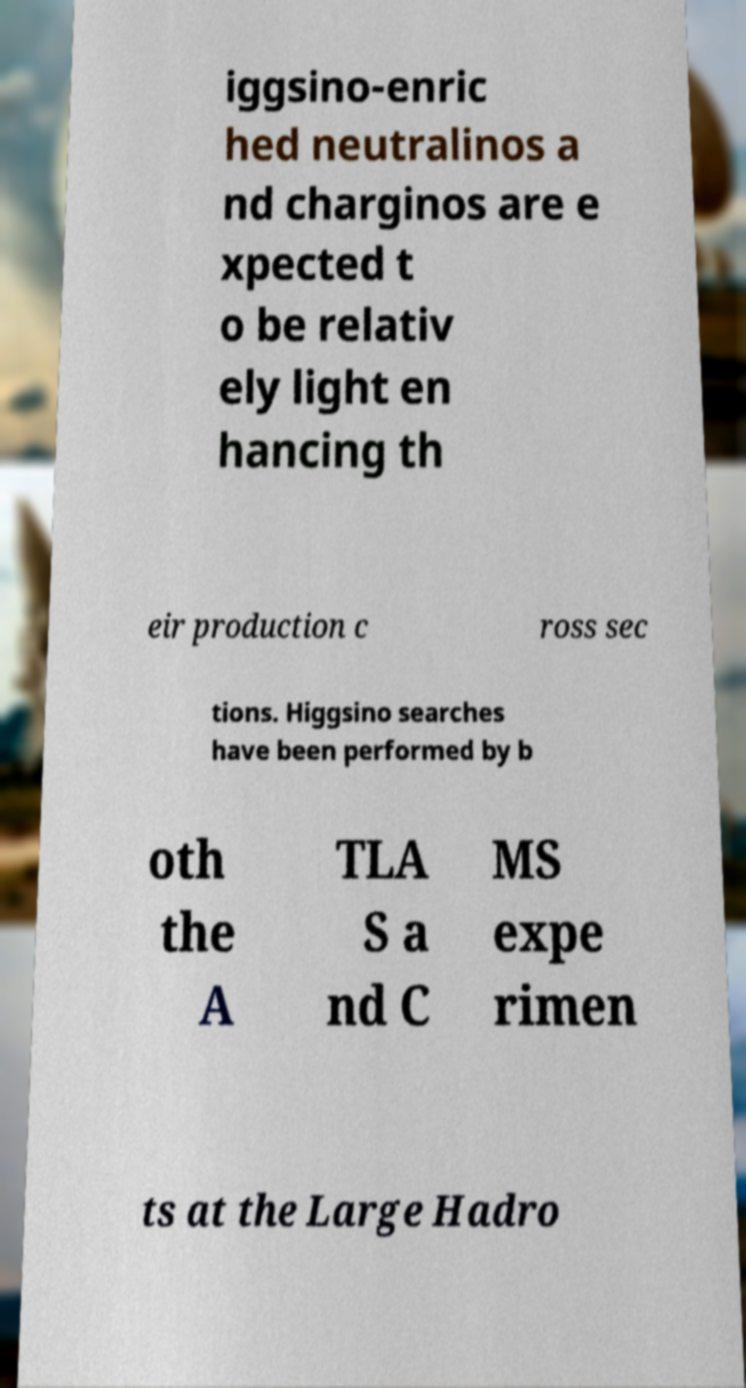There's text embedded in this image that I need extracted. Can you transcribe it verbatim? iggsino-enric hed neutralinos a nd charginos are e xpected t o be relativ ely light en hancing th eir production c ross sec tions. Higgsino searches have been performed by b oth the A TLA S a nd C MS expe rimen ts at the Large Hadro 